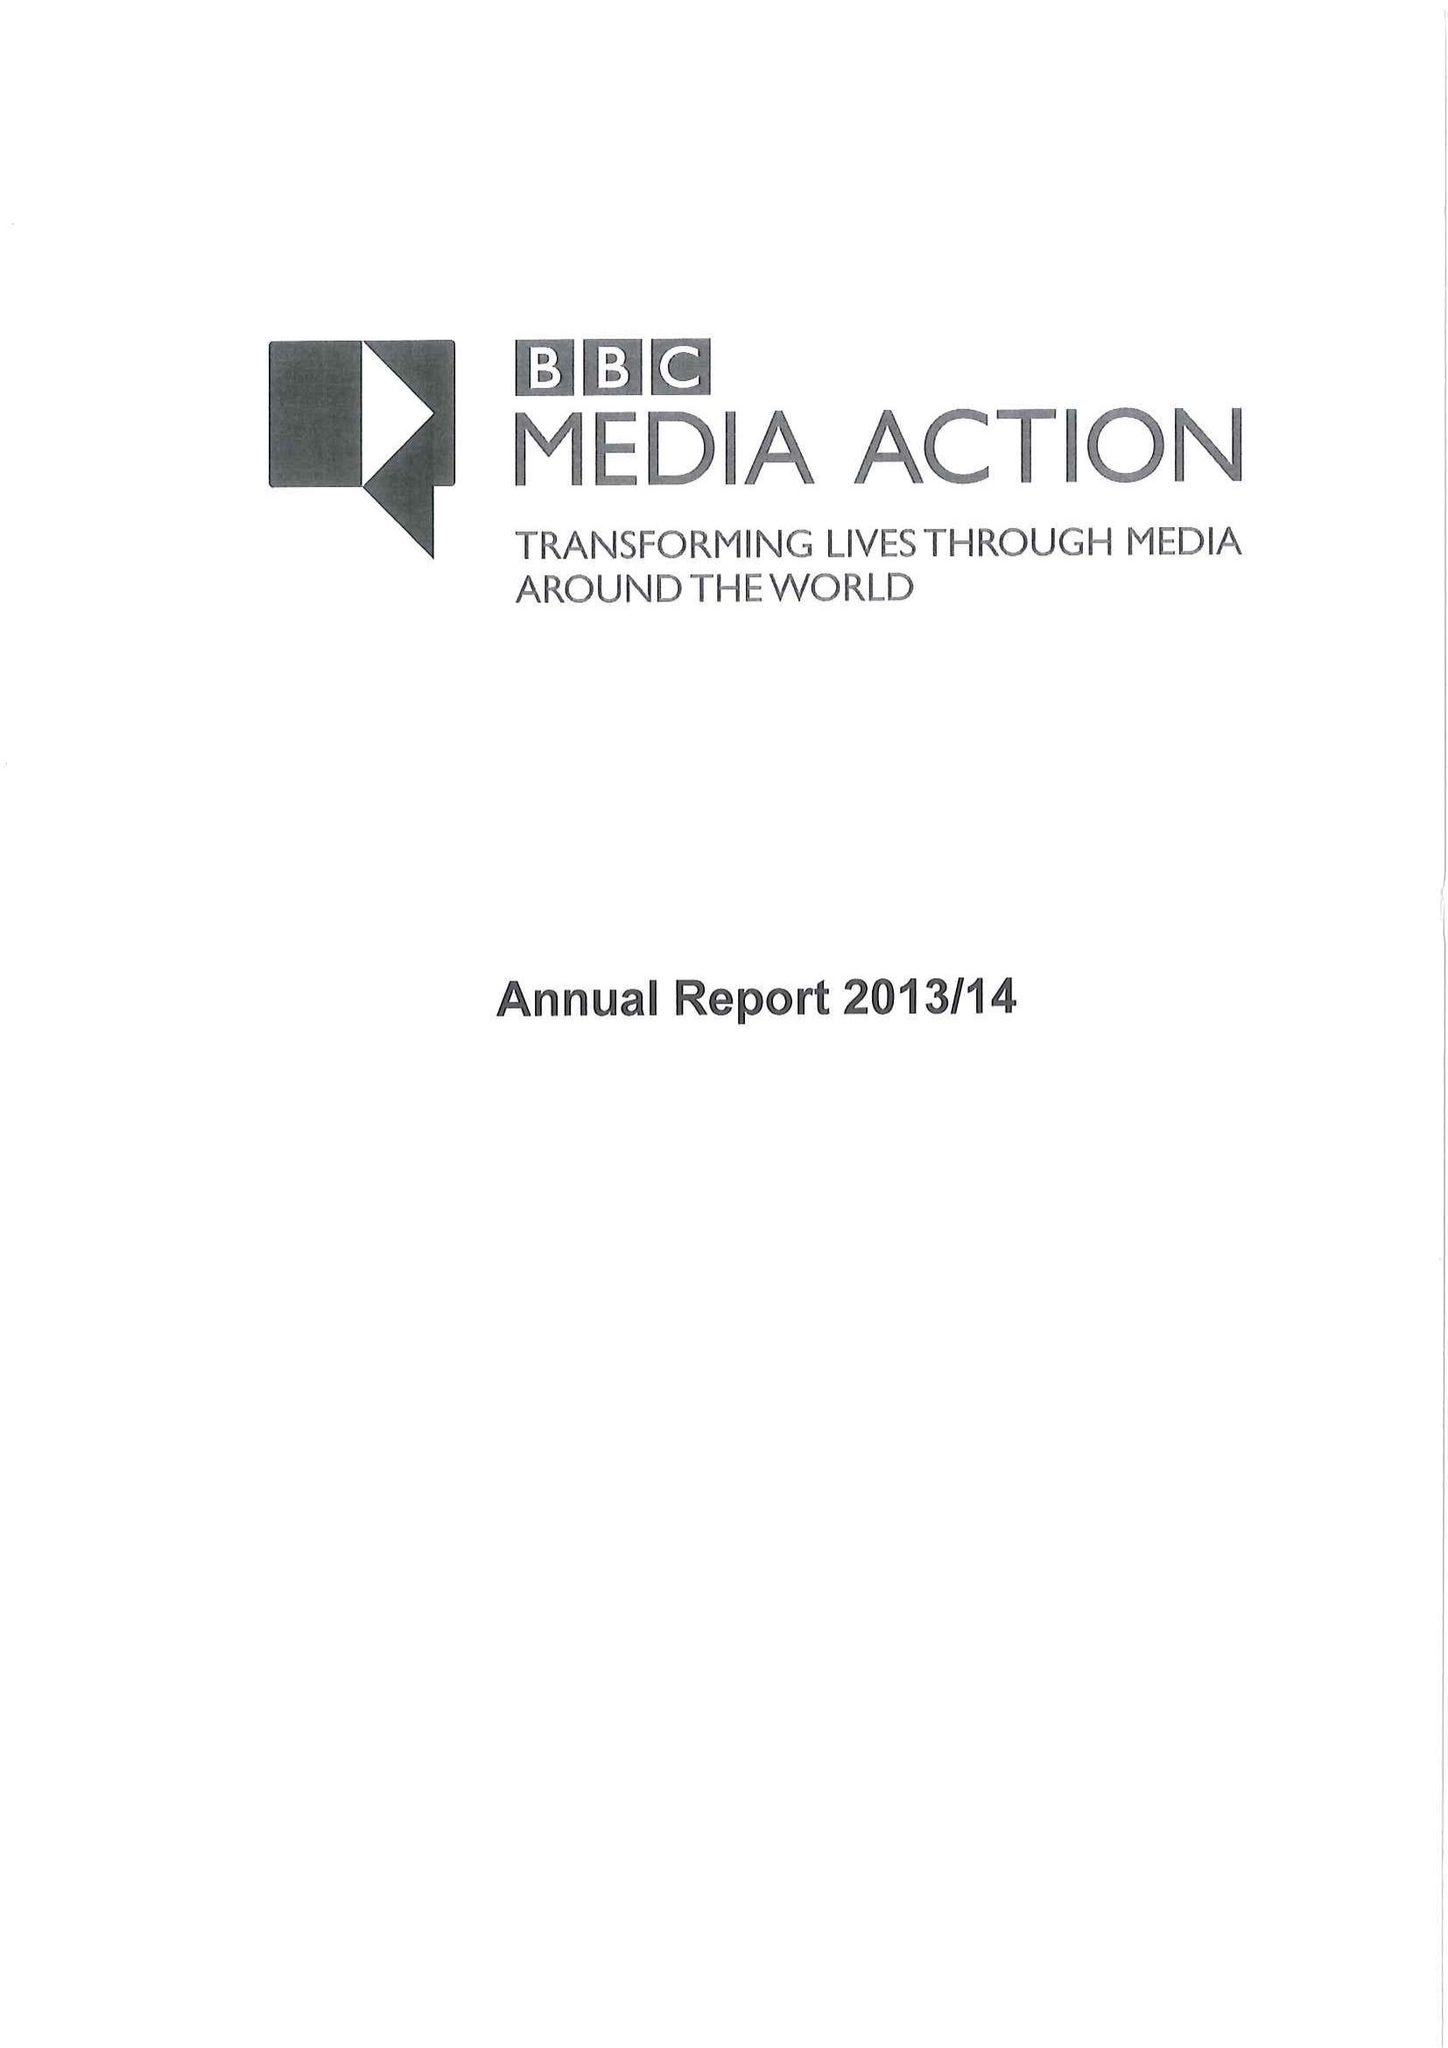What is the value for the report_date?
Answer the question using a single word or phrase. 2014-03-31 